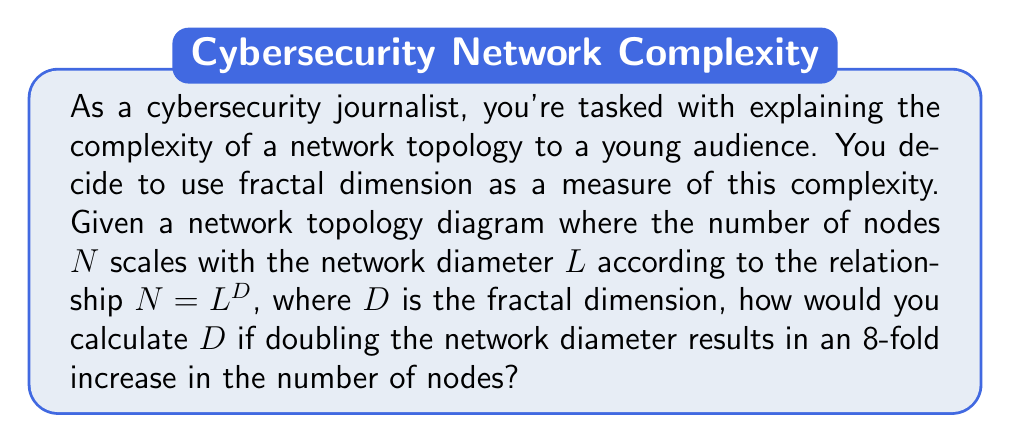Show me your answer to this math problem. To solve this problem, we'll follow these steps:

1) We're given that $N = L^D$, where:
   N = number of nodes
   L = network diameter
   D = fractal dimension

2) We're told that doubling the network diameter results in an 8-fold increase in nodes. Let's express this mathematically:

   If L becomes 2L, then N becomes 8N

3) Let's substitute these into our original equation:

   $8N = (2L)^D$

4) We can simplify the right side:

   $8N = 2^D \cdot L^D$

5) But remember, $N = L^D$, so we can substitute this on both sides:

   $8L^D = 2^D \cdot L^D$

6) The $L^D$ terms cancel out:

   $8 = 2^D$

7) Now we can solve for D using logarithms:

   $\log_2 8 = \log_2 2^D$

8) The right side simplifies to just D:

   $\log_2 8 = D$

9) We know that $\log_2 8 = 3$ because $2^3 = 8$

Therefore, D = 3

This means the fractal dimension of the network topology is 3, indicating a highly complex, three-dimensional-like structure in terms of how the number of nodes scales with the network's diameter.
Answer: $D = 3$ 